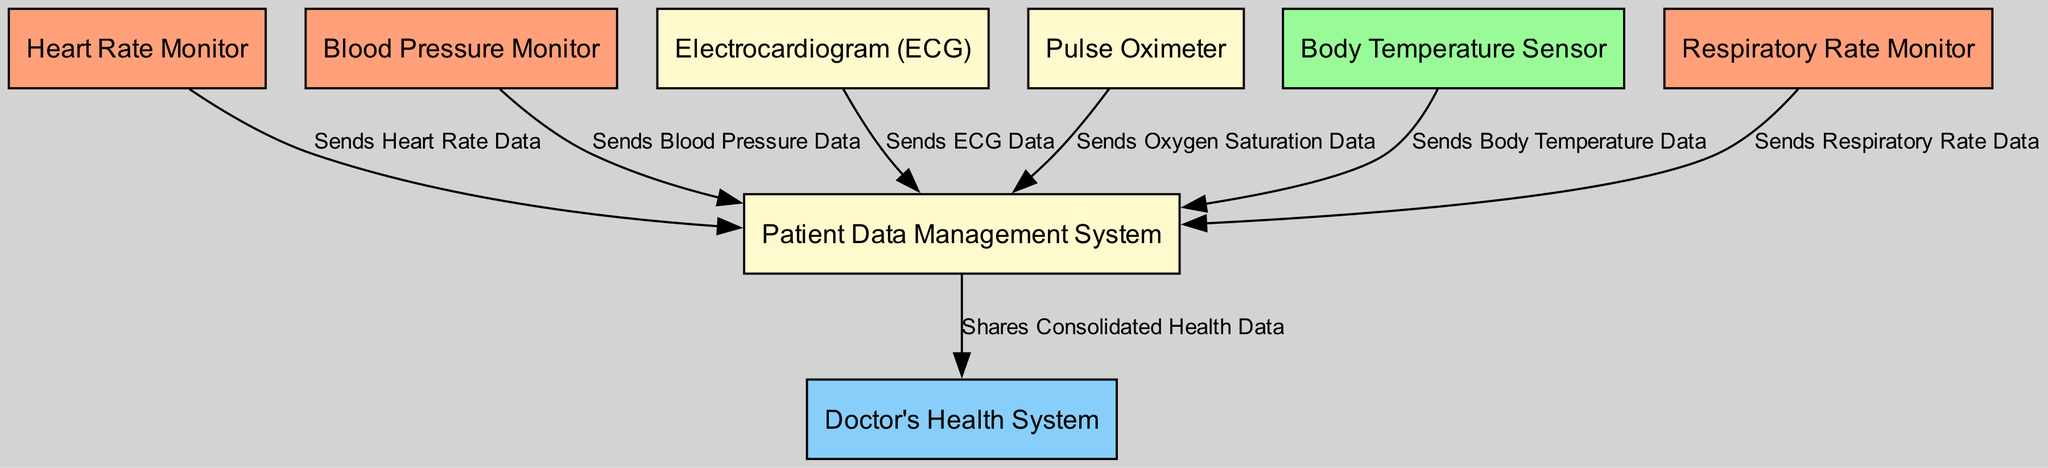What are the types of monitors included in the diagram? The diagram includes several types of monitors, which are nodes that specifically mention "monitor" in their label. These are Heart Rate Monitor, Blood Pressure Monitor, Electrocardiogram, and Respiratory Rate Monitor.
Answer: Heart Rate Monitor, Blood Pressure Monitor, Electrocardiogram, Respiratory Rate Monitor How many nodes are in the diagram? The diagram has a total of 8 nodes representing different components of the cardiovascular health monitoring system. These nodes include various monitors, sensors, and management systems.
Answer: 8 Which node sends oxygen saturation data? The data indicates that the Pulse Oximeter is responsible for sending oxygen saturation data to the Patient Data Management System, as evidenced by the directed edge in the diagram.
Answer: Pulse Oximeter What is the purpose of the Patient Data Management System? The Patient Data Management System is designed to consolidate and manage health data from various monitors and sensors before sharing it with the Doctor's Health System, illustrating its key role in information flow.
Answer: Consolidates health data How many edges are there in the diagram? The diagram contains 6 edges, each representing a specific data flow from the monitoring devices to the Patient Data Management System and subsequently to the Doctor's Health System, indicating connections between nodes.
Answer: 6 What information is shared between the Patient Data Management System and the Doctor's Health System? The edge from the Patient Data Management System to the Doctor's Health System indicates that it shares consolidated health data, highlighting the integration of patient information for healthcare professionals.
Answer: Consolidated health data Which node provides body temperature data? The temperature sensor is specifically identified in the diagram as the node that sends body temperature data to the Patient Data Management System, indicating its role in monitoring vital signs.
Answer: Body Temperature Sensor What color represents the monitors in the diagram? The nodes representing monitors in the diagram are filled with light salmon color, distinguishing them visually from other types of nodes such as sensors and systems.
Answer: Light Salmon 